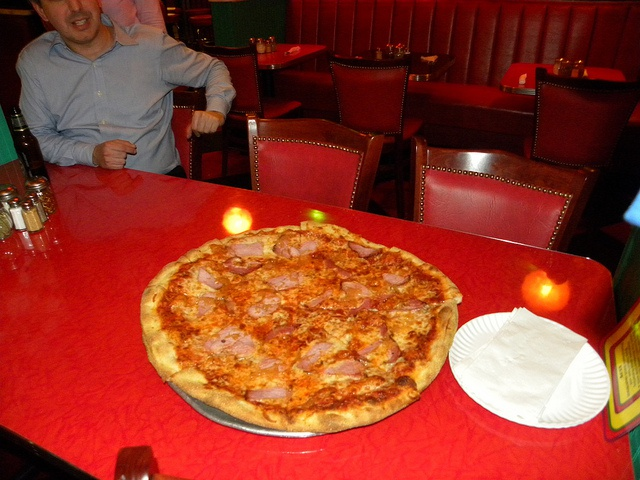Describe the objects in this image and their specific colors. I can see dining table in black, red, brown, and ivory tones, pizza in black, red, and orange tones, people in black, gray, maroon, and brown tones, chair in black, brown, and maroon tones, and chair in black, brown, and maroon tones in this image. 